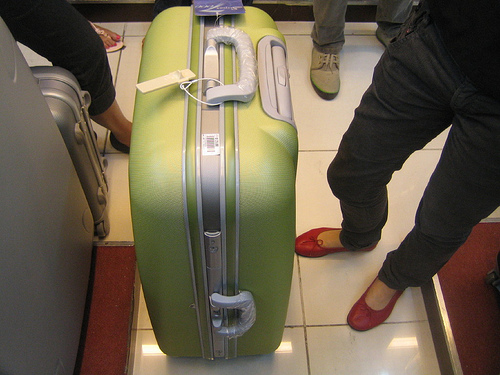<image>What recent decade was this color of suitcase popular? It is ambiguous to determine the decade this color of suitcase was popular. It could be the 60s, 70s, 80s or 1990s. What recent decade was this color of suitcase popular? I don't know in which recent decade the color of suitcase was popular. It can be in the 60's, 70's, 80's, or 1990s. 